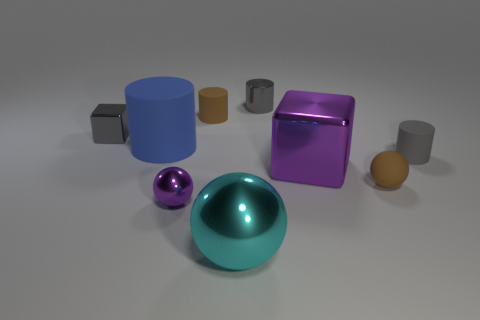There is a shiny thing that is both to the right of the large cyan metallic object and in front of the big blue object; what size is it? The shiny object to the right of the large cyan cylinder and in front of the large blue cube appears to be medium-sized compared to the surrounding objects. 